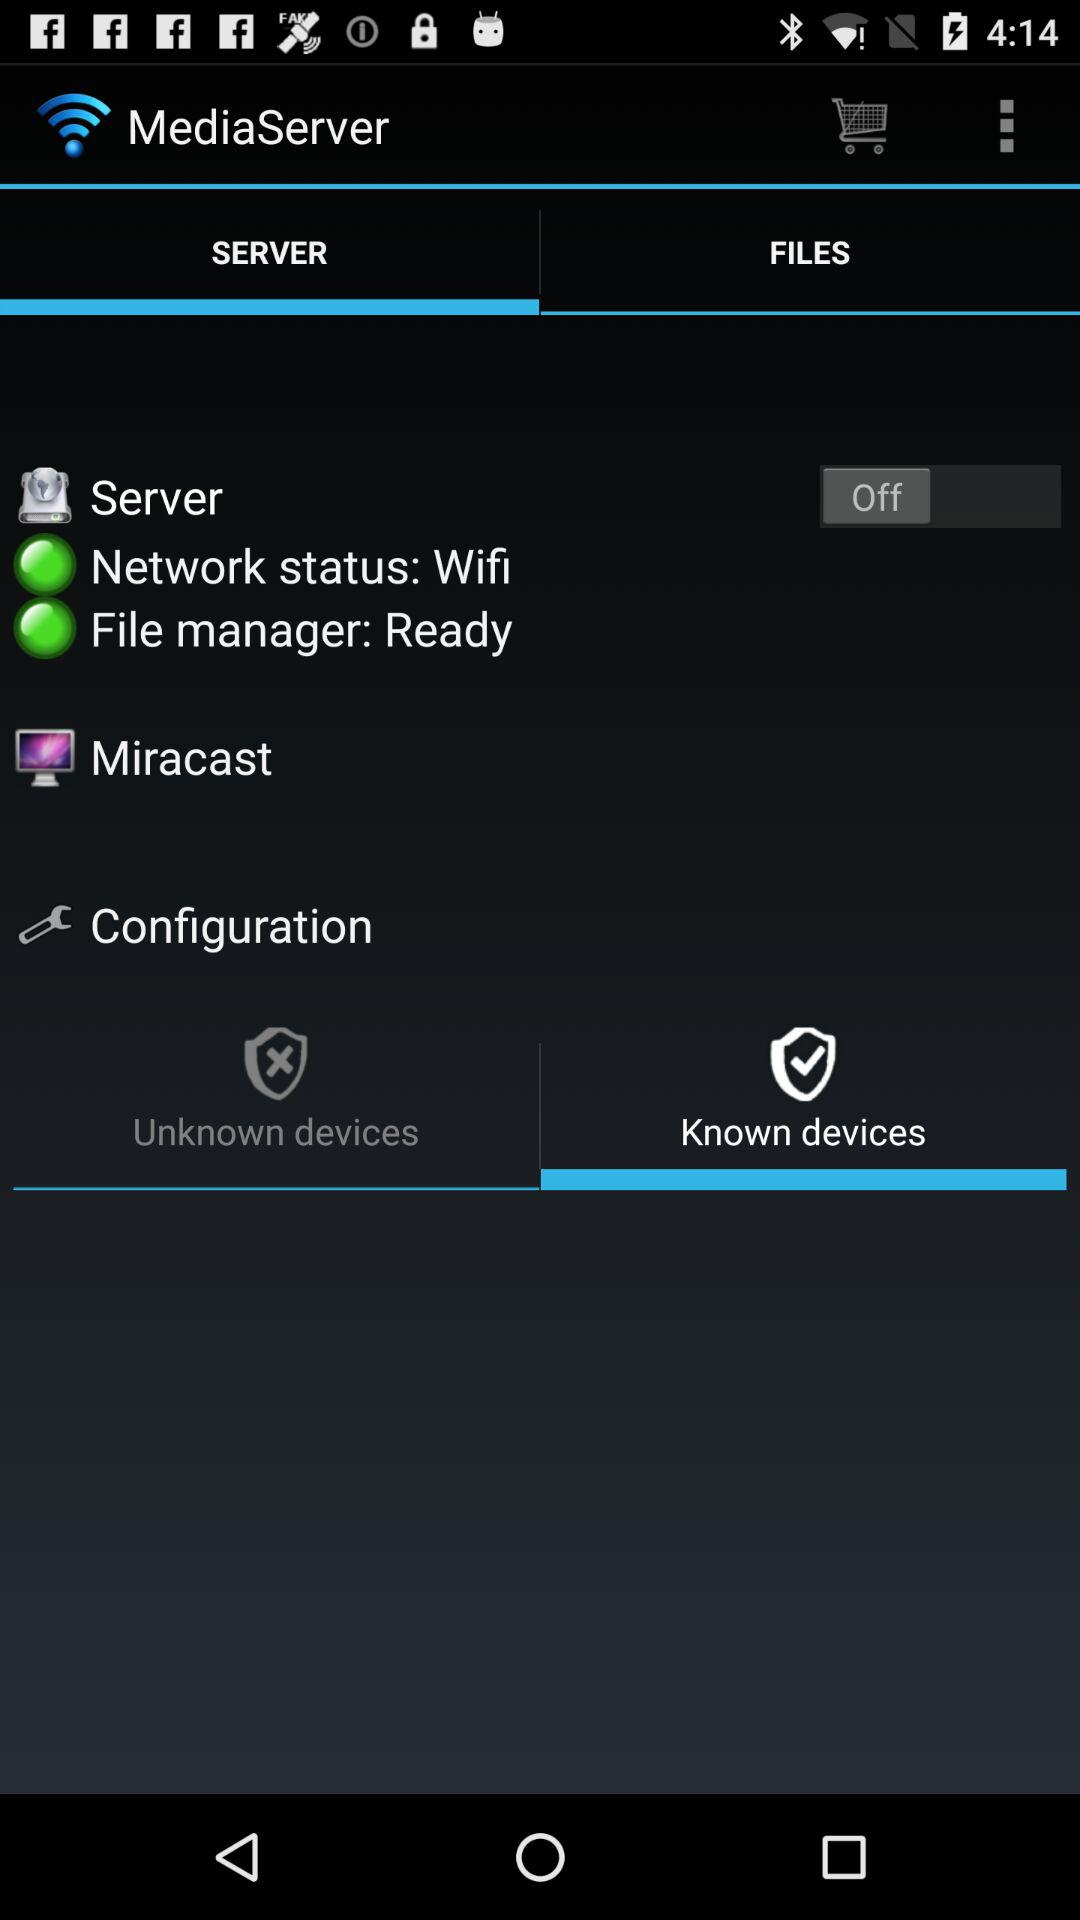Which option is selected? The selected options are "SERVER" and "Known devices". 